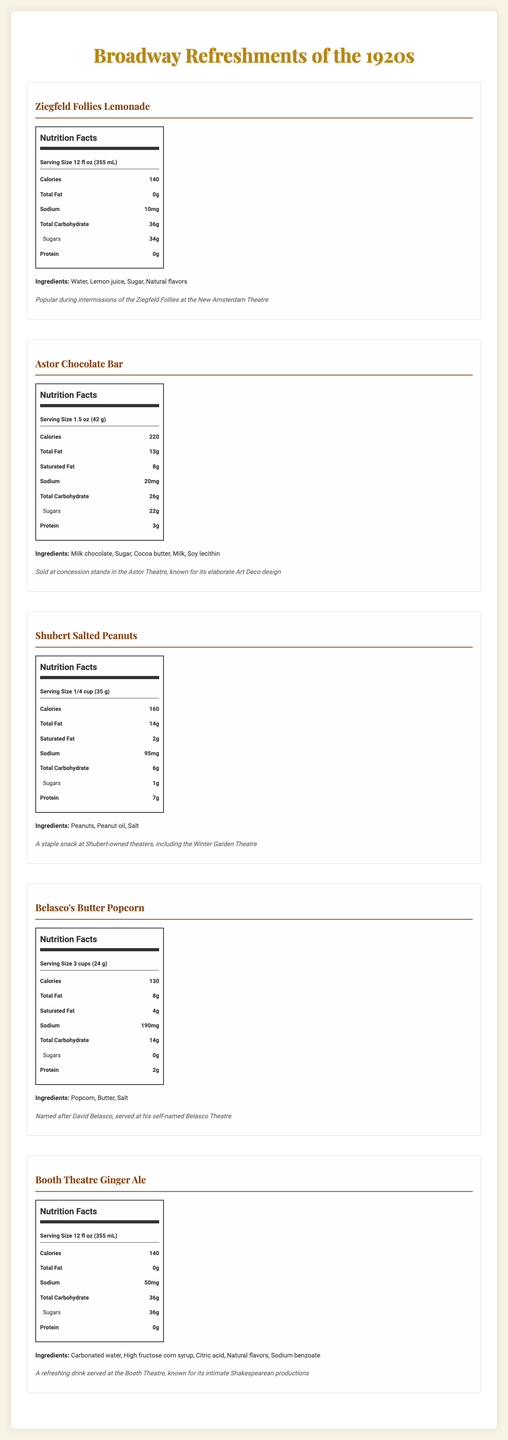what is the main ingredient in Ziegfeld Follies Lemonade? The ingredients for Ziegfeld Follies Lemonade are listed as Water, Lemon juice, Sugar, and Natural flavors; Water is the first ingredient.
Answer: Water how many grams of sugar are in Astor Chocolate Bar? The nutrition label for Astor Chocolate Bar indicates it contains 22 grams of sugar.
Answer: 22 grams which refreshment has the highest sodium content? A. Ziegfeld Follies Lemonade B. Astor Chocolate Bar C. Shubert Salted Peanuts D. Belasco's Butter Popcorn E. Booth Theatre Ginger Ale Belasco's Butter Popcorn has the highest sodium content at 190mg.
Answer: D how many calories does a serving of Shubert Salted Peanuts have? The nutrition label for Shubert Salted Peanuts shows it has 160 calories per serving.
Answer: 160 calories what is the serving size for Booth Theatre Ginger Ale? The serving size for Booth Theatre Ginger Ale is listed as 12 fl oz (355 mL).
Answer: 12 fl oz (355 mL) which refreshment is popular during intermissions of the Ziegfeld Follies? The historical note for Ziegfeld Follies Lemonade mentions it was popular during intermissions of the Ziegfeld Follies at the New Amsterdam Theatre.
Answer: Ziegfeld Follies Lemonade which refreshment contains the most protein per serving? A. Ziegfeld Follies Lemonade B. Astor Chocolate Bar C. Shubert Salted Peanuts D. Belasco's Butter Popcorn E. Booth Theatre Ginger Ale Shubert Salted Peanuts contains 7 grams of protein per serving, which is more than any of the other refreshments listed.
Answer: C. Shubert Salted Peanuts does Belasco's Butter Popcorn contain sugar? The nutrition label for Belasco's Butter Popcorn shows 0 grams of sugar.
Answer: No which refreshment includes High fructose corn syrup in its ingredients? Booth Theatre Ginger Ale lists HIGH fructose corn syrup as one of its ingredients.
Answer: Booth Theatre Ginger Ale which refreshment sold at an Art Deco designed theater? The historical note for Astor Chocolate Bar indicates it was sold at the Astor Theatre, known for its elaborate Art Deco design.
Answer: Astor Chocolate Bar what are the main refreshments sold at Broadway theaters in the 1920s? These are the refreshments listed in the document, each associated with a different theater.
Answer: Ziegfeld Follies Lemonade, Astor Chocolate Bar, Shubert Salted Peanuts, Belasco's Butter Popcorn, Booth Theatre Ginger Ale which refreshment has the highest calorie content? There's no direct information comparing all calorie contents in every snack/drink to conclude this exactly for all food and beverages.
Answer: Cannot be determined 